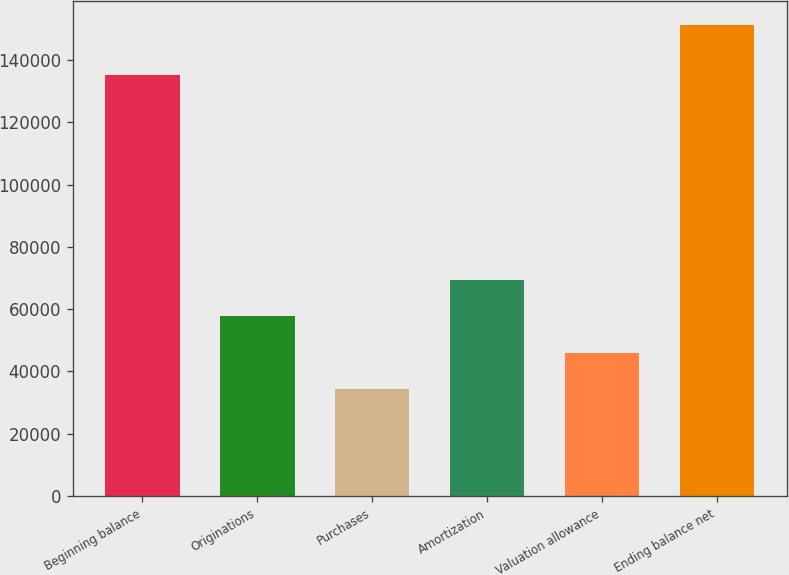Convert chart. <chart><loc_0><loc_0><loc_500><loc_500><bar_chart><fcel>Beginning balance<fcel>Originations<fcel>Purchases<fcel>Amortization<fcel>Valuation allowance<fcel>Ending balance net<nl><fcel>135076<fcel>57657.6<fcel>34243<fcel>69364.9<fcel>45950.3<fcel>151316<nl></chart> 